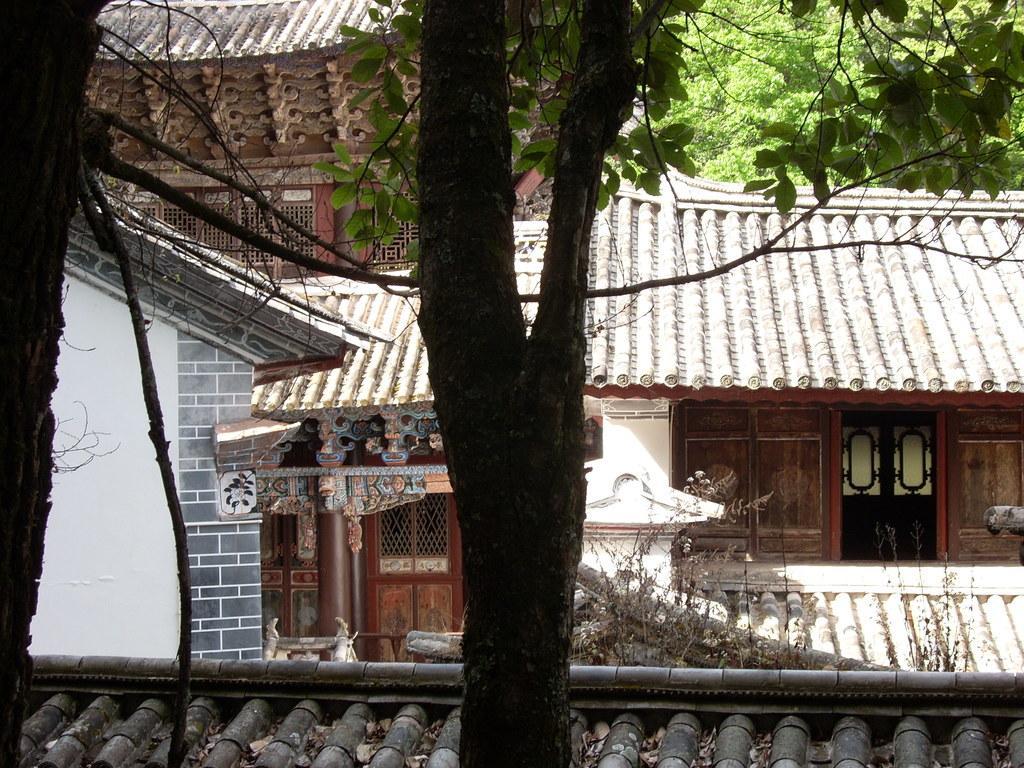Describe this image in one or two sentences. In this picture we can see few houses and trees. 